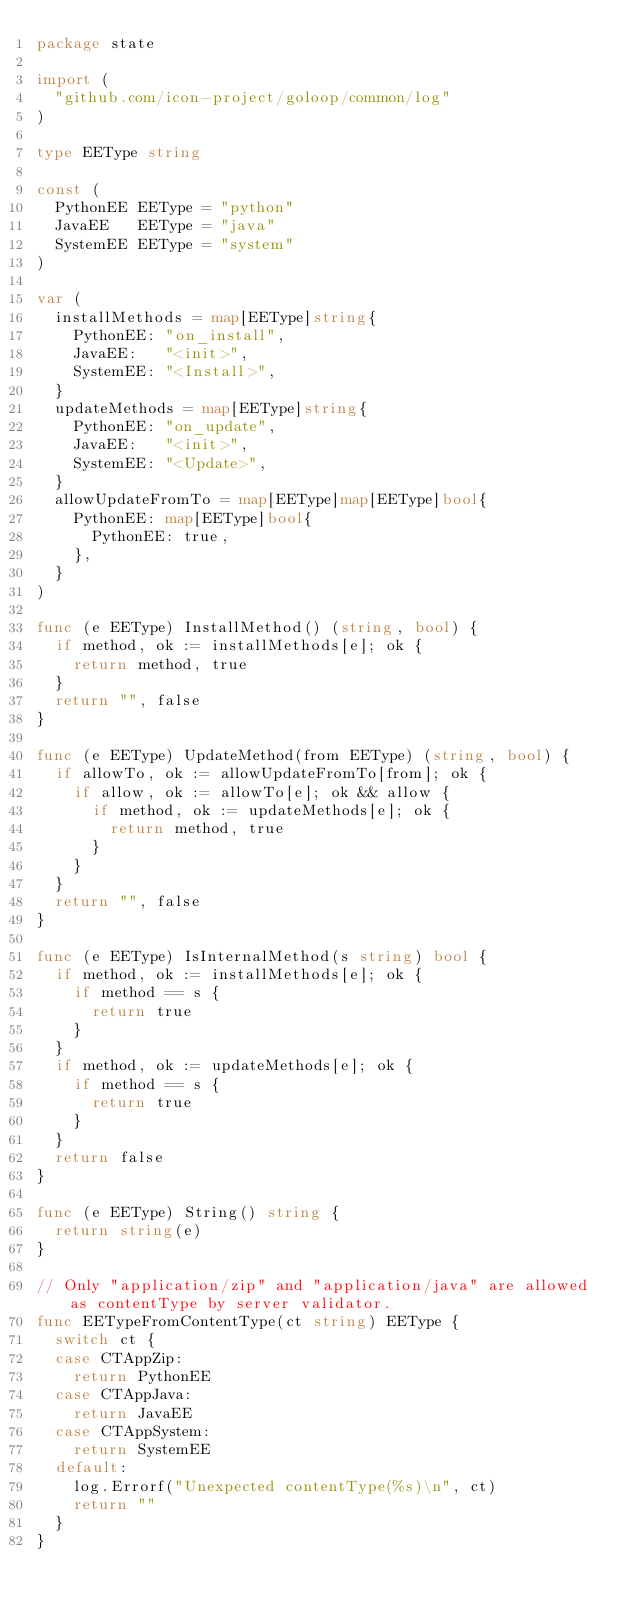Convert code to text. <code><loc_0><loc_0><loc_500><loc_500><_Go_>package state

import (
	"github.com/icon-project/goloop/common/log"
)

type EEType string

const (
	PythonEE EEType = "python"
	JavaEE   EEType = "java"
	SystemEE EEType = "system"
)

var (
	installMethods = map[EEType]string{
		PythonEE: "on_install",
		JavaEE:   "<init>",
		SystemEE: "<Install>",
	}
	updateMethods = map[EEType]string{
		PythonEE: "on_update",
		JavaEE:   "<init>",
		SystemEE: "<Update>",
	}
	allowUpdateFromTo = map[EEType]map[EEType]bool{
		PythonEE: map[EEType]bool{
			PythonEE: true,
		},
	}
)

func (e EEType) InstallMethod() (string, bool) {
	if method, ok := installMethods[e]; ok {
		return method, true
	}
	return "", false
}

func (e EEType) UpdateMethod(from EEType) (string, bool) {
	if allowTo, ok := allowUpdateFromTo[from]; ok {
		if allow, ok := allowTo[e]; ok && allow {
			if method, ok := updateMethods[e]; ok {
				return method, true
			}
		}
	}
	return "", false
}

func (e EEType) IsInternalMethod(s string) bool {
	if method, ok := installMethods[e]; ok {
		if method == s {
			return true
		}
	}
	if method, ok := updateMethods[e]; ok {
		if method == s {
			return true
		}
	}
	return false
}

func (e EEType) String() string {
	return string(e)
}

// Only "application/zip" and "application/java" are allowed as contentType by server validator.
func EETypeFromContentType(ct string) EEType {
	switch ct {
	case CTAppZip:
		return PythonEE
	case CTAppJava:
		return JavaEE
	case CTAppSystem:
		return SystemEE
	default:
		log.Errorf("Unexpected contentType(%s)\n", ct)
		return ""
	}
}
</code> 